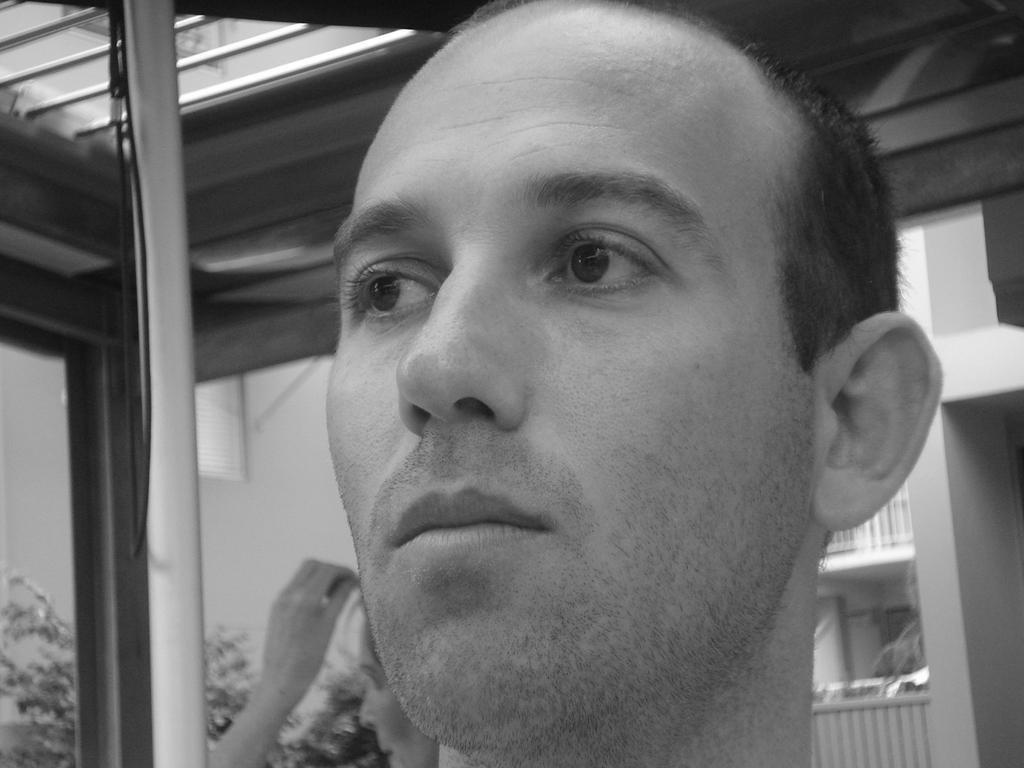What is the main subject of the image? The main subject of the image is a black and white picture of a person's head. Can you describe the background of the image? In the background of the image, there is another person, a building, a railing, and trees. What type of structure can be seen in the background? The structure in the background is a building. What color is the gold frog sitting on the railing in the image? There is no gold frog present in the image. 